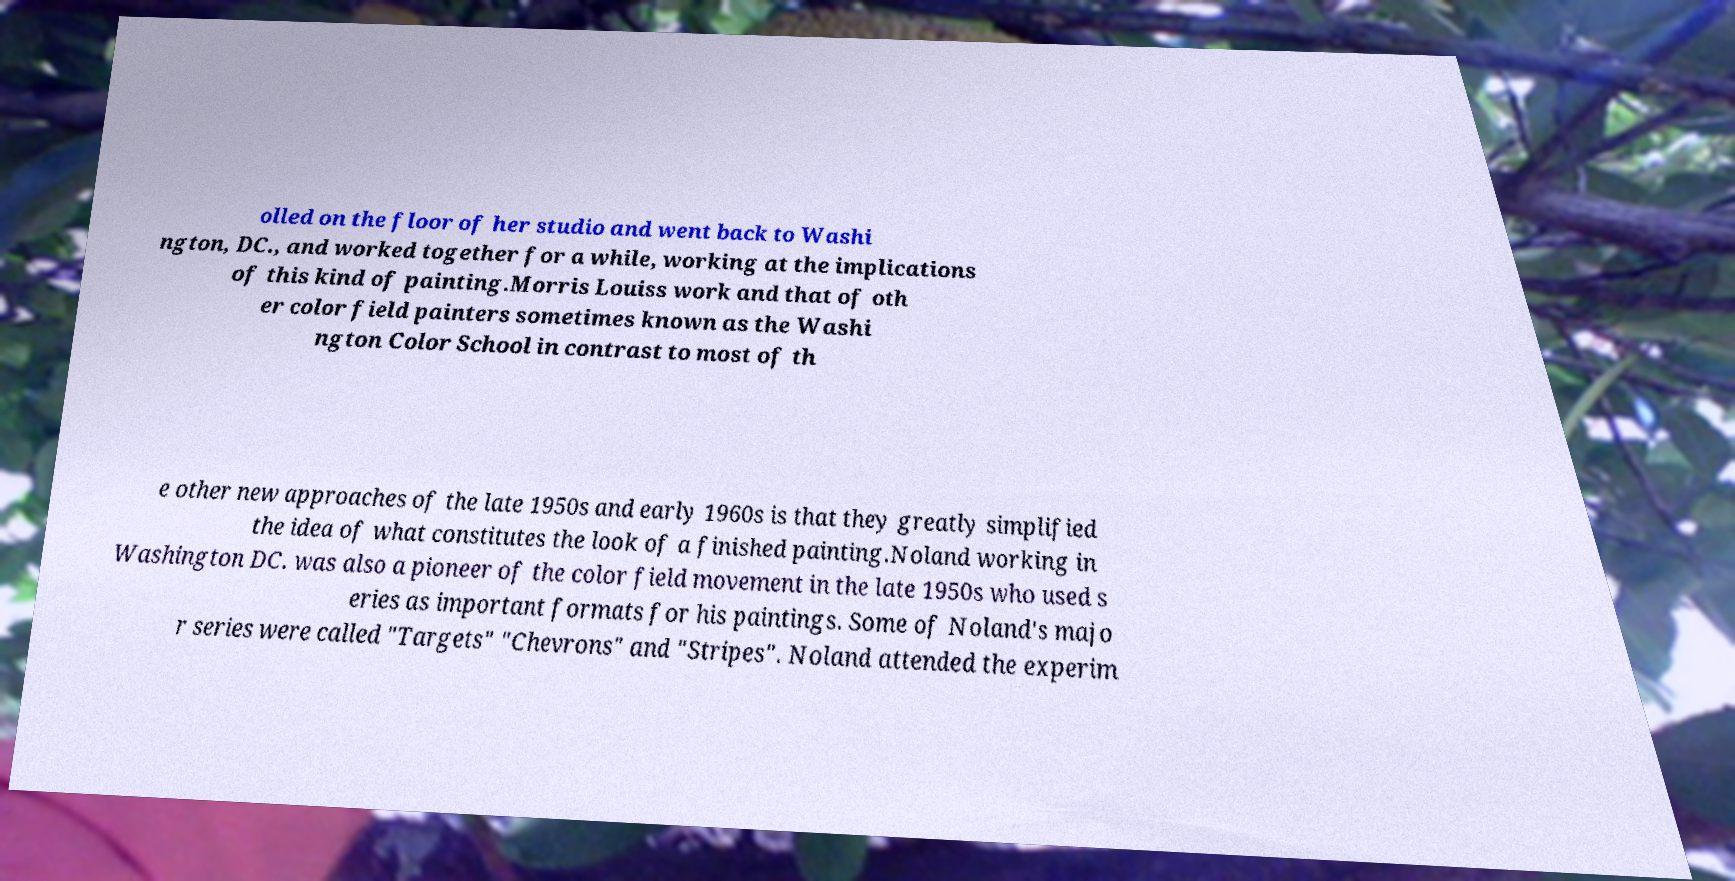Can you read and provide the text displayed in the image?This photo seems to have some interesting text. Can you extract and type it out for me? olled on the floor of her studio and went back to Washi ngton, DC., and worked together for a while, working at the implications of this kind of painting.Morris Louiss work and that of oth er color field painters sometimes known as the Washi ngton Color School in contrast to most of th e other new approaches of the late 1950s and early 1960s is that they greatly simplified the idea of what constitutes the look of a finished painting.Noland working in Washington DC. was also a pioneer of the color field movement in the late 1950s who used s eries as important formats for his paintings. Some of Noland's majo r series were called "Targets" "Chevrons" and "Stripes". Noland attended the experim 